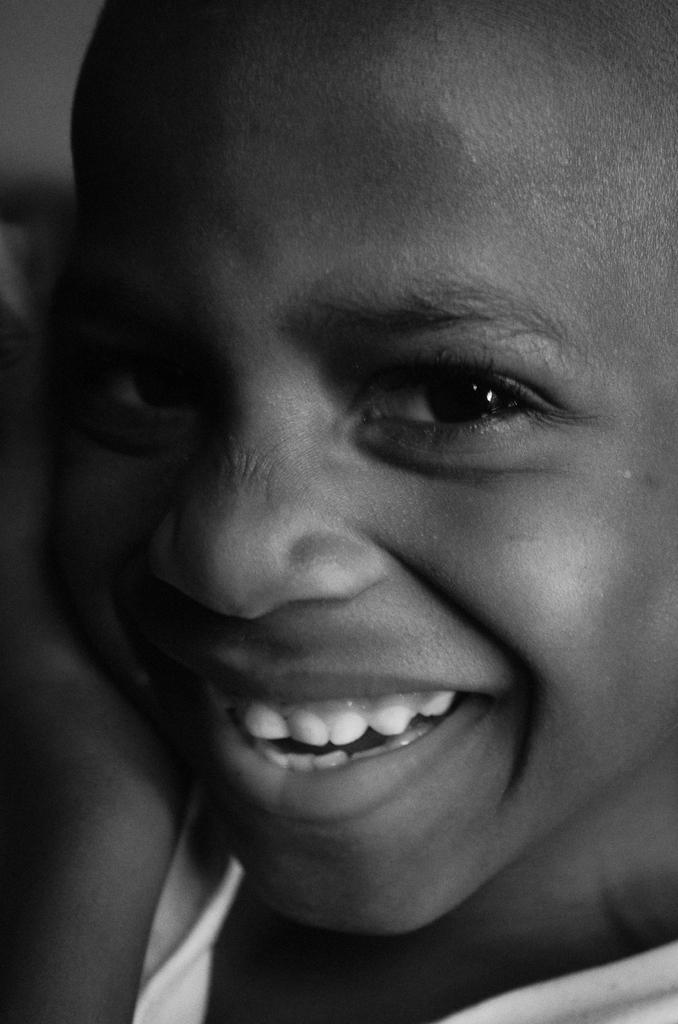What is the color scheme of the picture? The picture is black and white. What is the main subject of the image? There is a kid in the picture. What type of beast can be seen in the heart of the picture? There is no beast or heart present in the picture; it is a black and white image featuring a kid. 